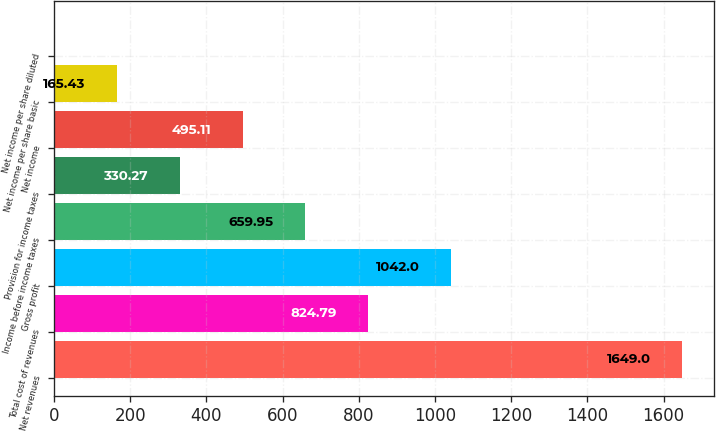Convert chart. <chart><loc_0><loc_0><loc_500><loc_500><bar_chart><fcel>Net revenues<fcel>Total cost of revenues<fcel>Gross profit<fcel>Income before income taxes<fcel>Provision for income taxes<fcel>Net income<fcel>Net income per share basic<fcel>Net income per share diluted<nl><fcel>1649<fcel>824.79<fcel>1042<fcel>659.95<fcel>330.27<fcel>495.11<fcel>165.43<fcel>0.59<nl></chart> 